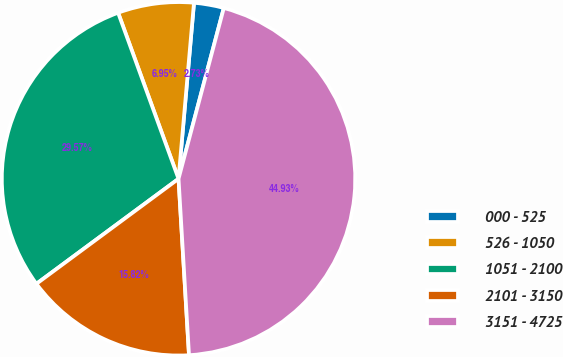Convert chart. <chart><loc_0><loc_0><loc_500><loc_500><pie_chart><fcel>000 - 525<fcel>526 - 1050<fcel>1051 - 2100<fcel>2101 - 3150<fcel>3151 - 4725<nl><fcel>2.73%<fcel>6.95%<fcel>29.58%<fcel>15.82%<fcel>44.94%<nl></chart> 